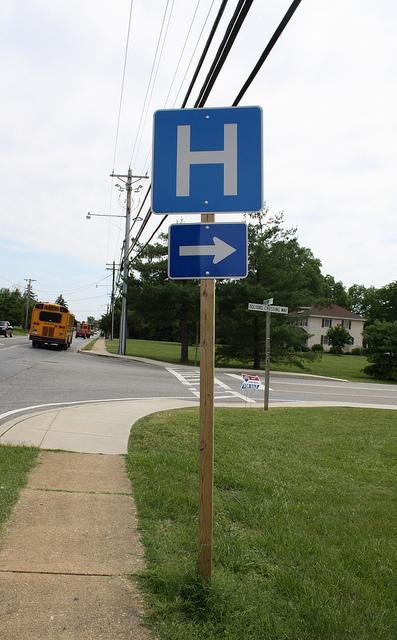What kind of sign is red?
Give a very brief answer. None. What color is the bus?
Keep it brief. Yellow. What does the blue writing say?
Keep it brief. H. What color is the sign?
Write a very short answer. Blue. Are there any leaves on the tree on the right side of the picture?
Concise answer only. Yes. What kind of tree is across the crosswalk?
Concise answer only. Oak. Is the grass green or brown?
Short answer required. Green. Who is allowed to walk around here?
Write a very short answer. Anyone. How many miles to Kingstown?
Keep it brief. 0. Is there a Mobil gas station close by?
Keep it brief. No. What does the bottom sign say?
Give a very brief answer. Right. Is this a park?
Keep it brief. No. Which way would you go if you needed to go to the hospital?
Concise answer only. Right. What is casting a shadow?
Concise answer only. Sign. Do the signs look professional?
Concise answer only. Yes. Is there a sidewalk in this picture?
Be succinct. Yes. How many dogs are in this picture?
Concise answer only. 0. 